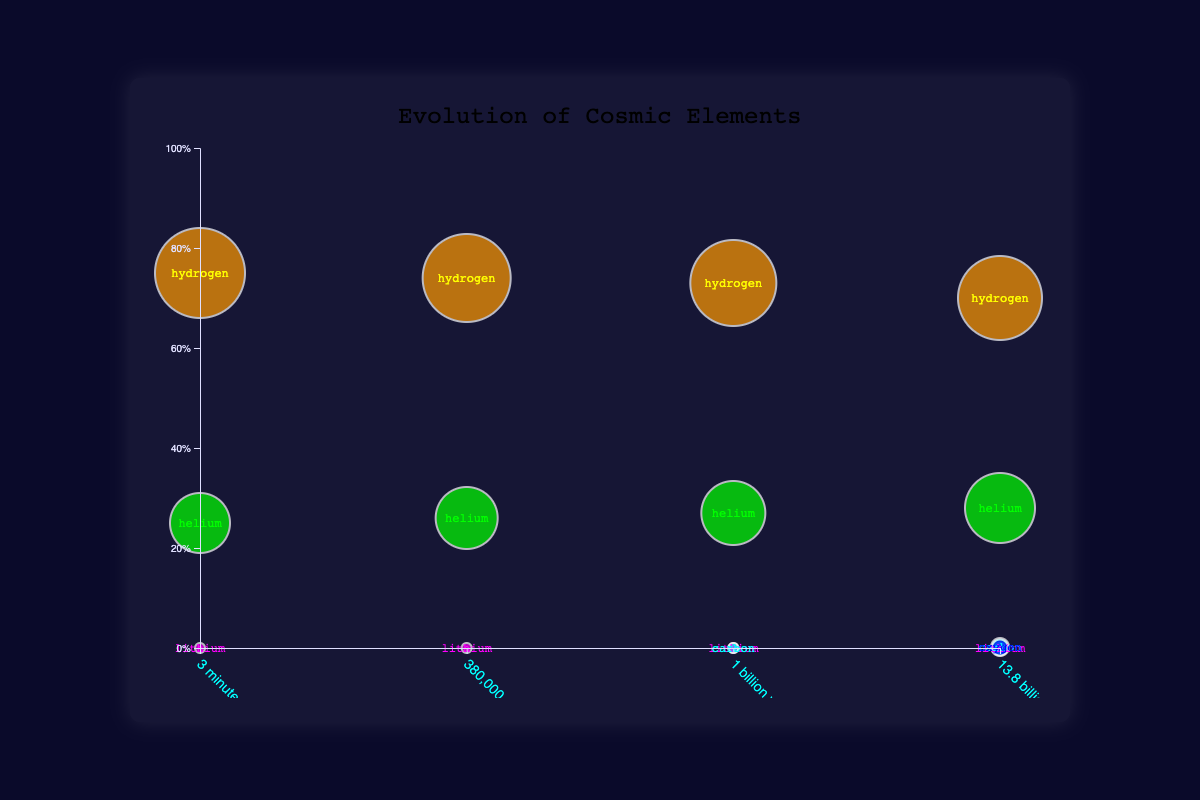What is the title of the figure? The title is displayed at the top center of the chart in a larger, distinct font. It is typically the most visible text on the chart.
Answer: Evolution of Cosmic Elements How does the proportion of hydrogen change from "3 minutes after Big Bang" to "13.8 billion years (Present Day)"? The proportion of hydrogen decreases over time. At "3 minutes after Big Bang", it starts at 0.75, and by "13.8 billion years (Present Day)", it decreases to 0.7.
Answer: Decreases from 0.75 to 0.7 What element appears for the first time at "1 billion years after Big Bang"? Analyzing the data points, carbon appears for the first time at this time period, as indicated by its presence in the corresponding bubble.
Answer: Carbon How many elements are represented in the "13.8 billion years (Present Day)" period? Observing the bubbles, Present Day features bubbles for hydrogen, helium, lithium, carbon, and oxygen, making it five elements.
Answer: Five Compare the size of the hydrogen bubble between "3 minutes after Big Bang" and "13.8 billion years (Present Day)". The bubble size for hydrogen is 45 at "3 minutes after Big Bang" and 42 at "13.8 billion years (Present Day)". The hydrogen bubble size has decreased by 3 units.
Answer: Decreased by 3 units Which element has the smallest bubble size across all time periods? In all time periods, the lithium bubble size is consistently 5, which is the smallest size among all elements shown.
Answer: Lithium At "1 billion years after the Big Bang," what is the combined proportion of hydrogen and helium? The proportions of hydrogen and helium are 0.73 and 0.27, respectively. Summing them gives 0.73 + 0.27 = 1.00.
Answer: 1.00 Which time period shows the highest proportion of helium? Observing the helium data points, the highest proportion is 0.28 at "13.8 billion years (Present Day)".
Answer: 13.8 billion years (Present Day) What is the total bubble size for carbon across all time periods? The bubble size for carbon is 5 at "1 billion years after Big Bang" and 9 at "13.8 billion years (Present Day)". The total size is 5 + 9 = 14.
Answer: 14 